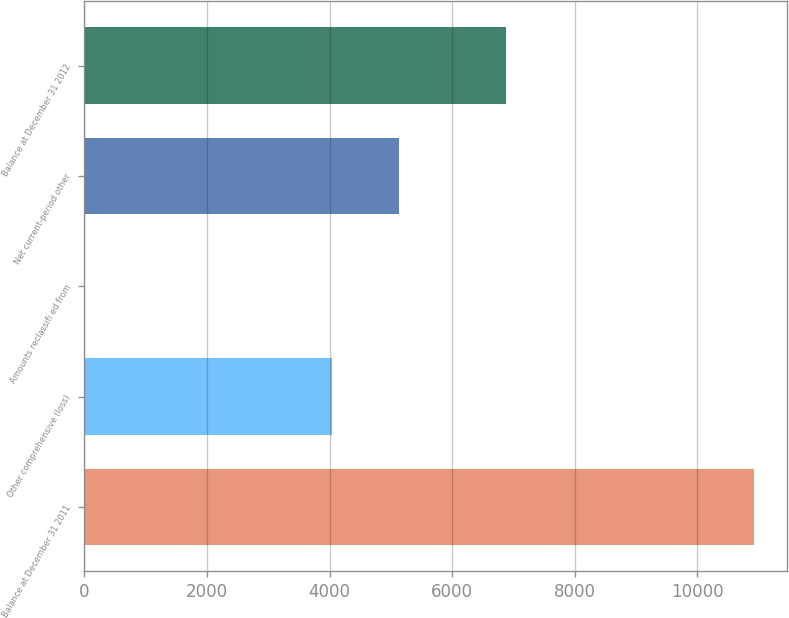Convert chart to OTSL. <chart><loc_0><loc_0><loc_500><loc_500><bar_chart><fcel>Balance at December 31 2011<fcel>Other comprehensive (loss)<fcel>Amounts reclassifi ed from<fcel>Net current-period other<fcel>Balance at December 31 2012<nl><fcel>10918<fcel>4036<fcel>4.85<fcel>5127.32<fcel>6882<nl></chart> 